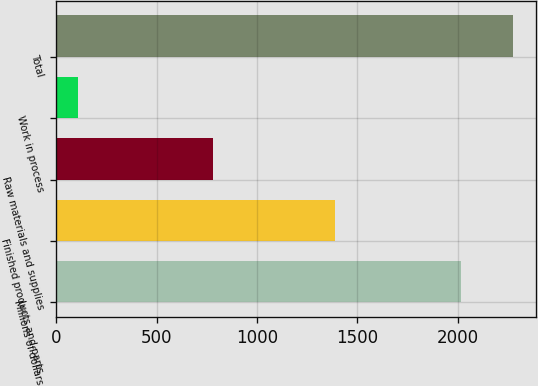Convert chart to OTSL. <chart><loc_0><loc_0><loc_500><loc_500><bar_chart><fcel>Millions of dollars<fcel>Finished products and parts<fcel>Raw materials and supplies<fcel>Work in process<fcel>Total<nl><fcel>2016<fcel>1388<fcel>778<fcel>109<fcel>2275<nl></chart> 